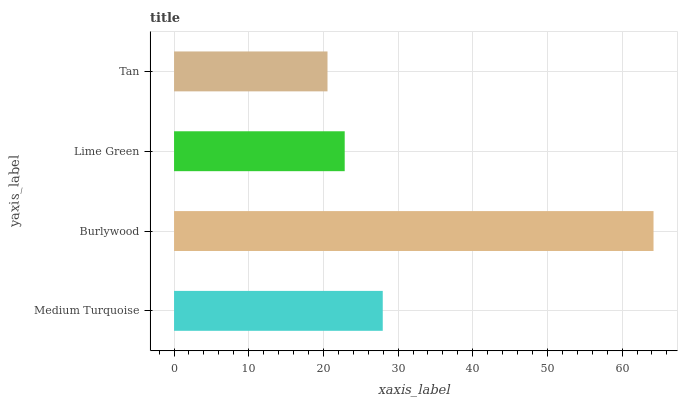Is Tan the minimum?
Answer yes or no. Yes. Is Burlywood the maximum?
Answer yes or no. Yes. Is Lime Green the minimum?
Answer yes or no. No. Is Lime Green the maximum?
Answer yes or no. No. Is Burlywood greater than Lime Green?
Answer yes or no. Yes. Is Lime Green less than Burlywood?
Answer yes or no. Yes. Is Lime Green greater than Burlywood?
Answer yes or no. No. Is Burlywood less than Lime Green?
Answer yes or no. No. Is Medium Turquoise the high median?
Answer yes or no. Yes. Is Lime Green the low median?
Answer yes or no. Yes. Is Tan the high median?
Answer yes or no. No. Is Medium Turquoise the low median?
Answer yes or no. No. 